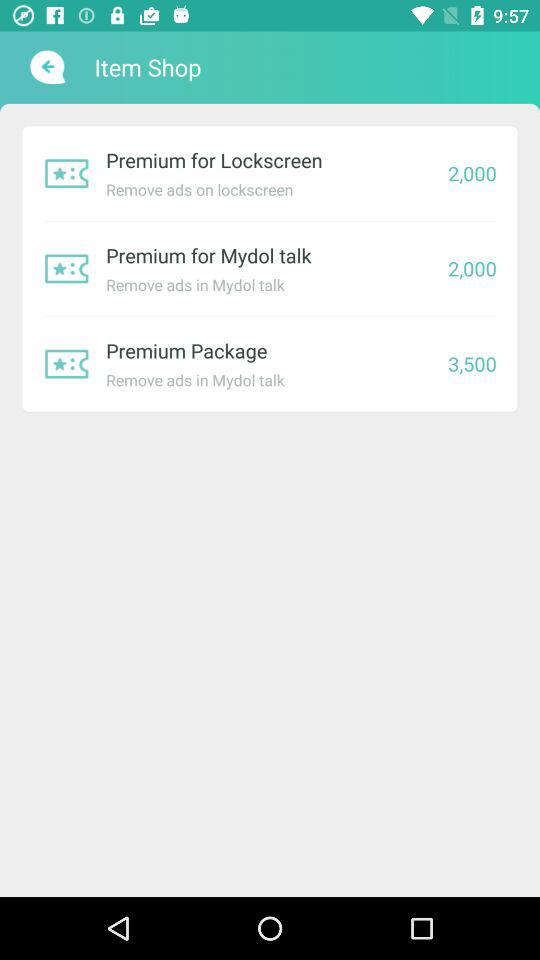What is the price of the premium for Mydol Talk? The price of the premium for Mydol Talk is 2,000. 